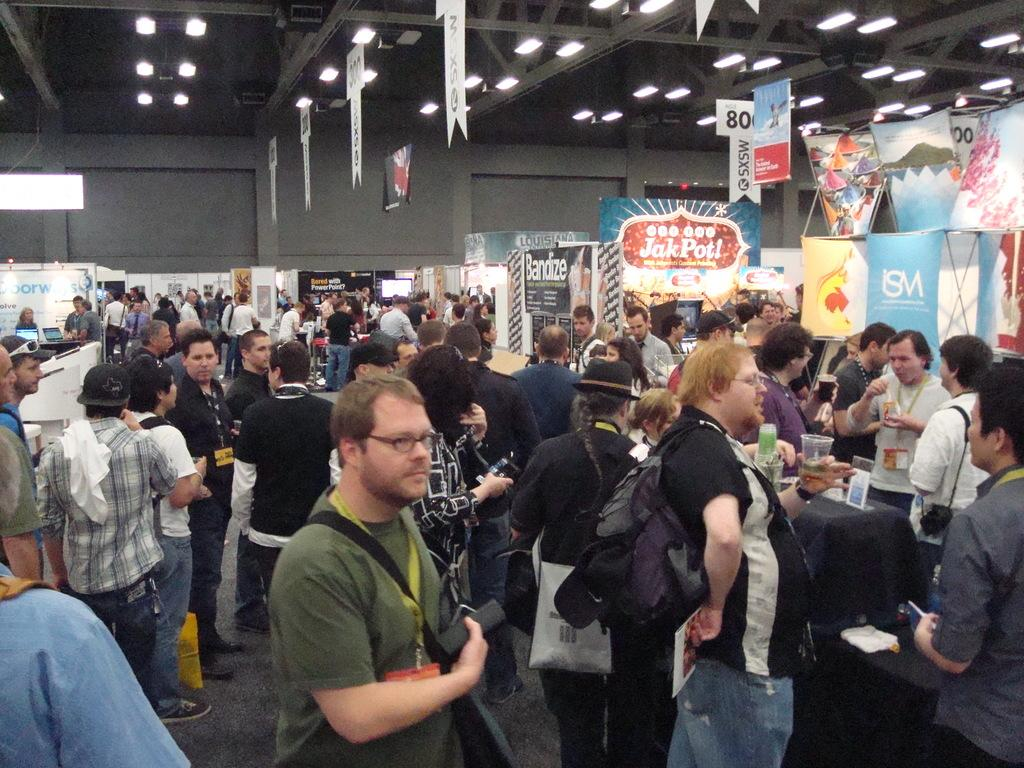What can be seen on the path in the image? There are many people on the path in the image. What objects are on the table in the image? There are boards on a table in the image. What is visible on top in the image? There are boards and lights visible on top in the image. What is on the wall in the image? There is a screen on the wall in the image. Can you see a connection between the ocean and the people on the path in the image? There is no ocean visible in the image, so it is not possible to see a connection between the ocean and the people on the path. What is the condition of the person's knee in the image? There are no people's knees visible in the image, so it is not possible to determine the condition of any knee. 